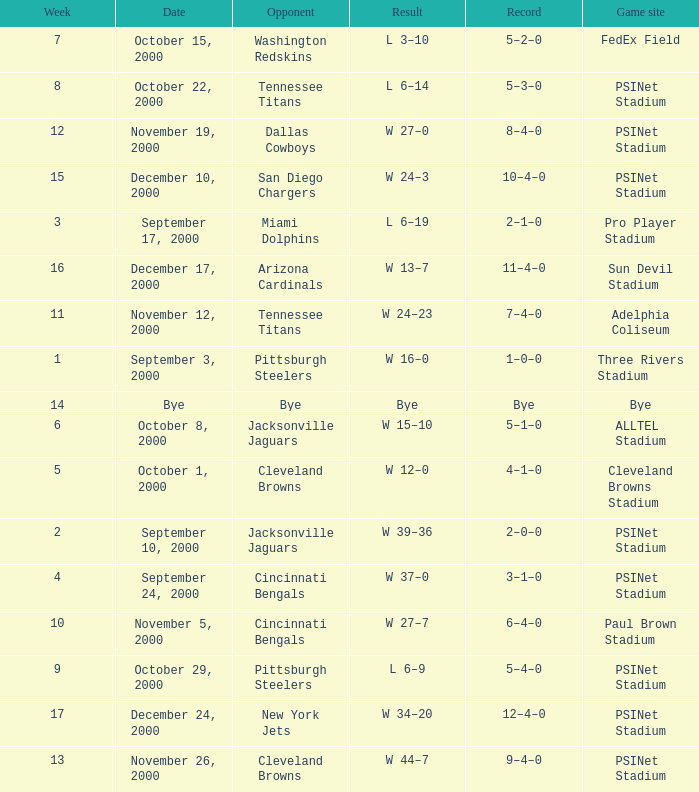What's the record for October 8, 2000 before week 13? 5–1–0. 